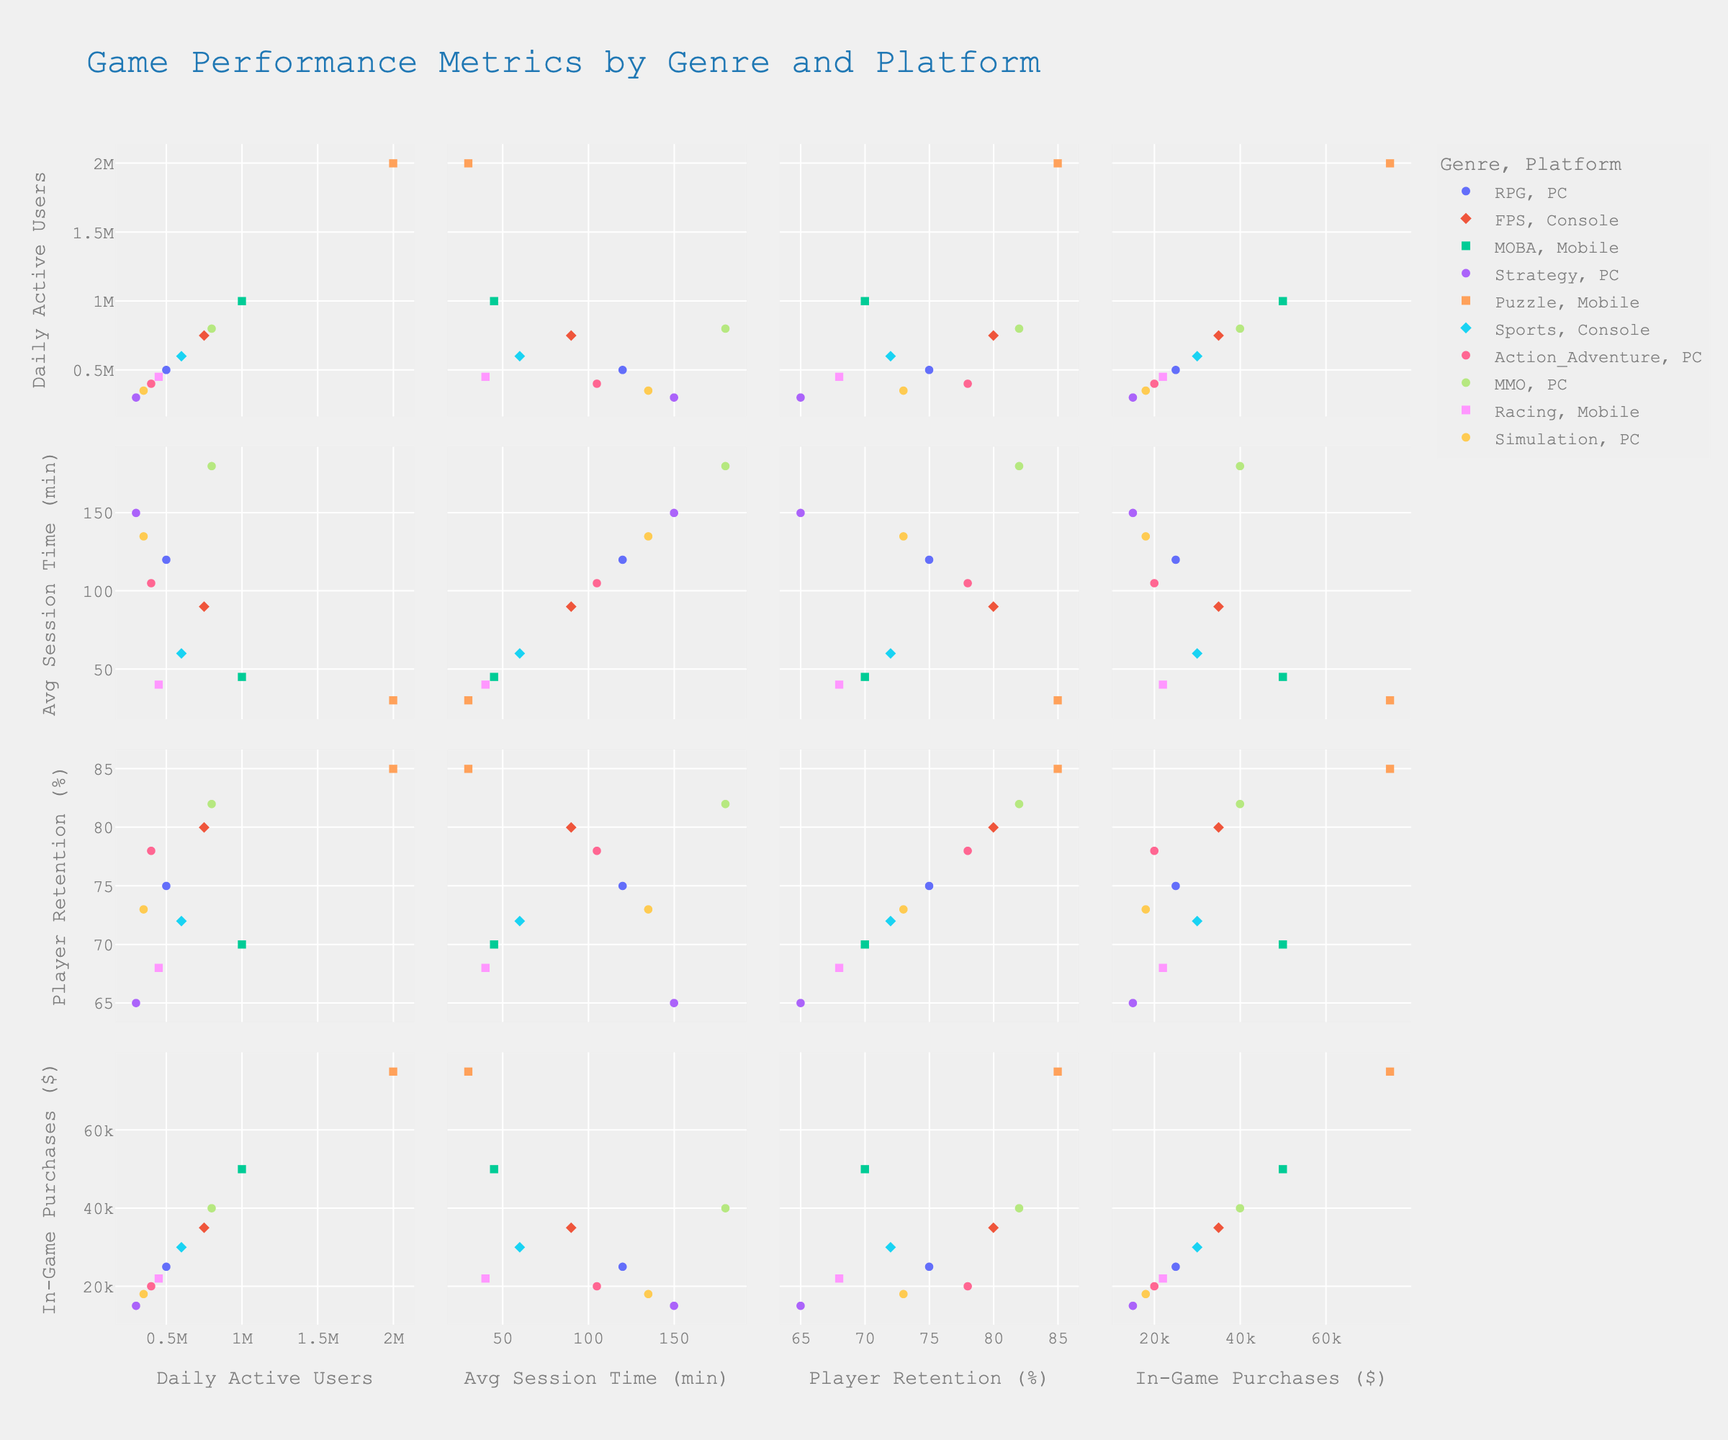How many data points are representing the Puzzle genre? To find this, look for the color representing the Puzzle genre and count all data points with that color across all scatter plots in the matrix.
Answer: Five Which platform has more daily active users for FPS games, PC or Console? Observe the plot dimension representing Daily Active Users against Genre, locate the points for FPS games, and compare the DAU values for different platforms.
Answer: Console What's the average session time for RPG games? Look at the data points for RPG games in the Average Session Time axis. Identify the session times and compute their average: RPG has only one point with a session time of 120 minutes.
Answer: 120 minutes Which genre has the highest daily active users? Examine the matrix and look at the uppermost data point in the Daily Active Users dimension to identify the corresponding genre.
Answer: Puzzle Do mobile platforms generally have higher player retention rates than PC platforms? Compare the data points labeled as Mobile with those labeled as PC in the Player Retention Rate dimension to determine which platform has higher retention rates.
Answer: Yes Which genre/platform combination has the most in-game purchases? Identify the highest value in the In-Game Purchases dimension and check which genre and platform that data point represents.
Answer: Puzzle/Mobile Are there any genres with less than 50% player retention rate? Examine all data points in the Player Retention Rate dimension to see if any of them fall below the 50% mark, paying attention to their genre labels.
Answer: No What is the relationship between average session time and player retention rate for MMO games? Look at points representing MMO games, then compare the points in the respective dimensions of Average Session Time and Player Retention Rate to identify any trend.
Answer: Positive correlation Which genre has a higher average session time on PC: RPG, Strategy, or MMO? Compare the average session times for RPG, Strategy, and MMO genres on PC by checking the respective points in the Average Session Time dimension.
Answer: MMO Which data point represents the highest in-game purchases for mobile platforms, and what are its Daily Active Users? Locate the highest point in the In-Game Purchases dimension for Mobile platforms and check the Daily Active Users dimension for that point.
Answer: Puzzle, 2,000,000 